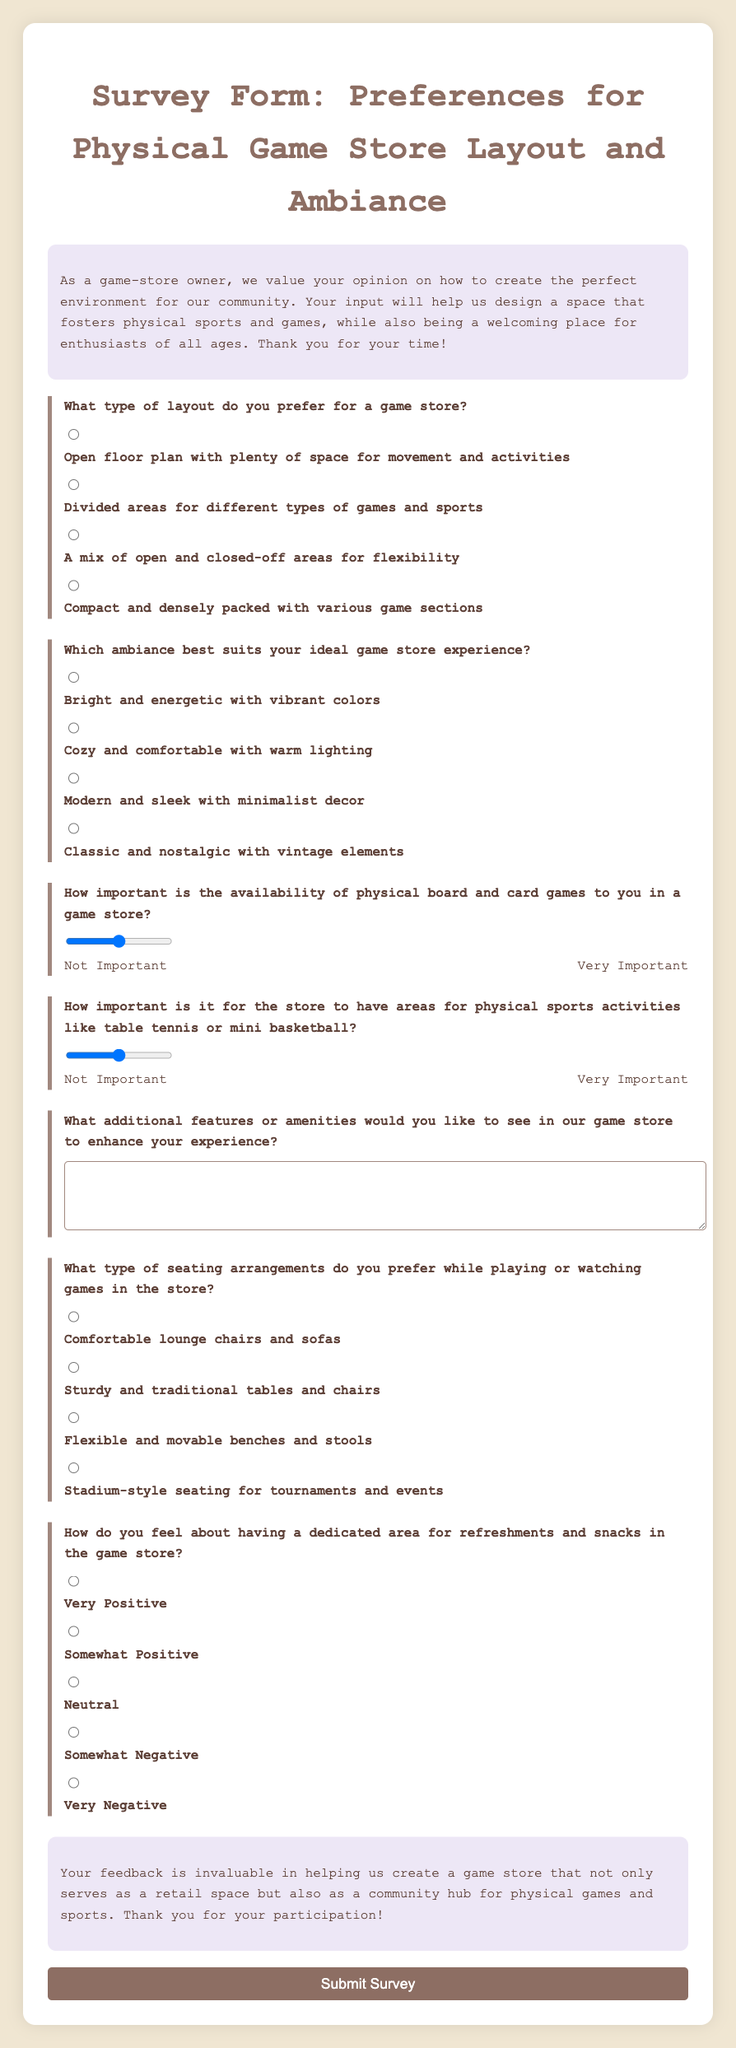What is the title of the survey form? The title of the survey form is prominently displayed at the top of the document, which is "Survey Form: Preferences for Physical Game Store Layout and Ambiance."
Answer: Survey Form: Preferences for Physical Game Store Layout and Ambiance What layout option has the value of "compact"? The layout option that has the value of "compact" is listed under the question regarding type of layout preferred in the store.
Answer: Compact and densely packed with various game sections How many types of seating arrangements are offered in the survey? The types of seating arrangements mentioned in the survey are categorized into four distinct options provided to the participants.
Answer: Four What scale is used to rate the importance of physical board games? The survey uses a rating scale that ranges from 1 to 5, indicating the level of importance assigned to physical board and card games.
Answer: 1 to 5 Which ambiance is described as being warm? The ambiance described as warm is categorized as "Cozy and comfortable with warm lighting" in the survey options.
Answer: Cozy What type of area is emphasized for physical sports activities? The survey specifically asks participants about the importance of having areas designated for physical sports activities.
Answer: Areas for physical sports activities What is the sentiment regarding refreshments according to the options? The sentiment concerning refreshments offers participants a multi-tiered option for expressing their feelings, ranging from very positive to very negative.
Answer: Very Positive to Very Negative What additional feature is asked for in the survey? The survey includes a question that requests suggestions for any additional features or amenities that could enhance the game store experience.
Answer: Additional features or amenities How does the survey conclude its message? The conclusion of the survey thanks participants for their feedback and highlights its importance for enhancing the community aspect of the game store.
Answer: Thank you for your participation! 